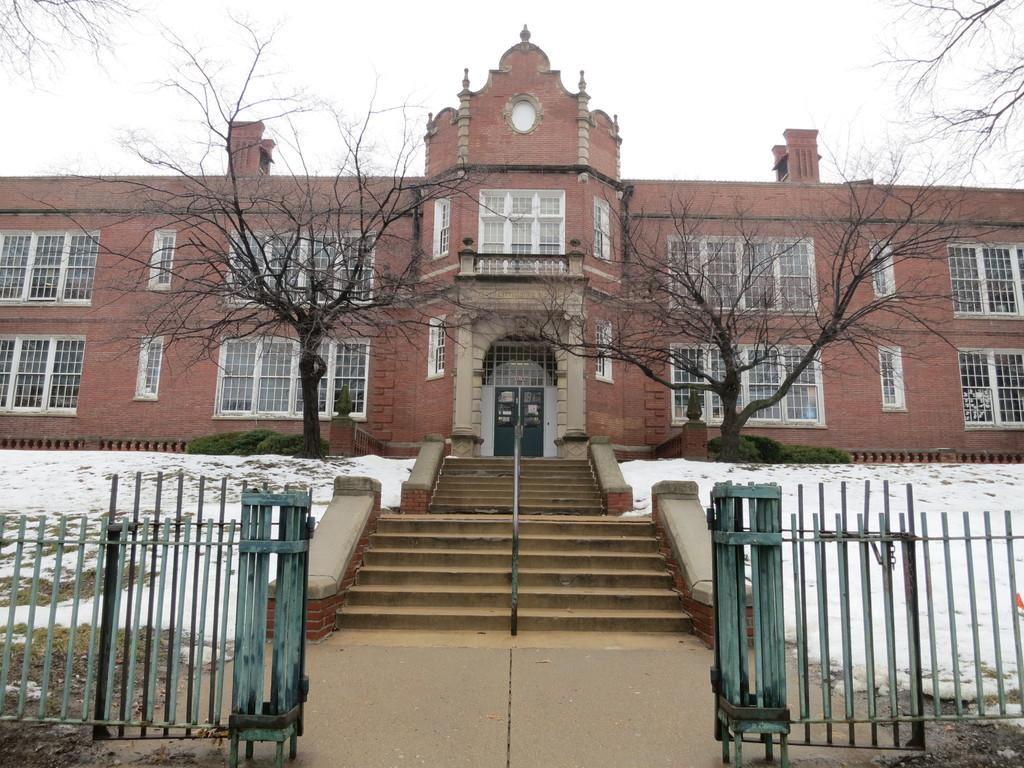What type of structure is present in the image? There is a building in the image. What is located in front of the building? There is a staircase in front of the building. What can be seen surrounding the building? There is a green fence and trees in the image. What is visible at the top of the image? The sky is visible at the top of the image. What type of music can be heard coming from the pump in the image? There is no pump or music present in the image. 